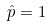<formula> <loc_0><loc_0><loc_500><loc_500>\hat { p } = 1</formula> 